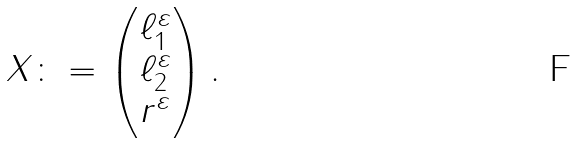Convert formula to latex. <formula><loc_0><loc_0><loc_500><loc_500>X \colon = \begin{pmatrix} \ell ^ { \varepsilon } _ { 1 } \\ \ell ^ { \varepsilon } _ { 2 } \\ r ^ { \varepsilon } \end{pmatrix} .</formula> 